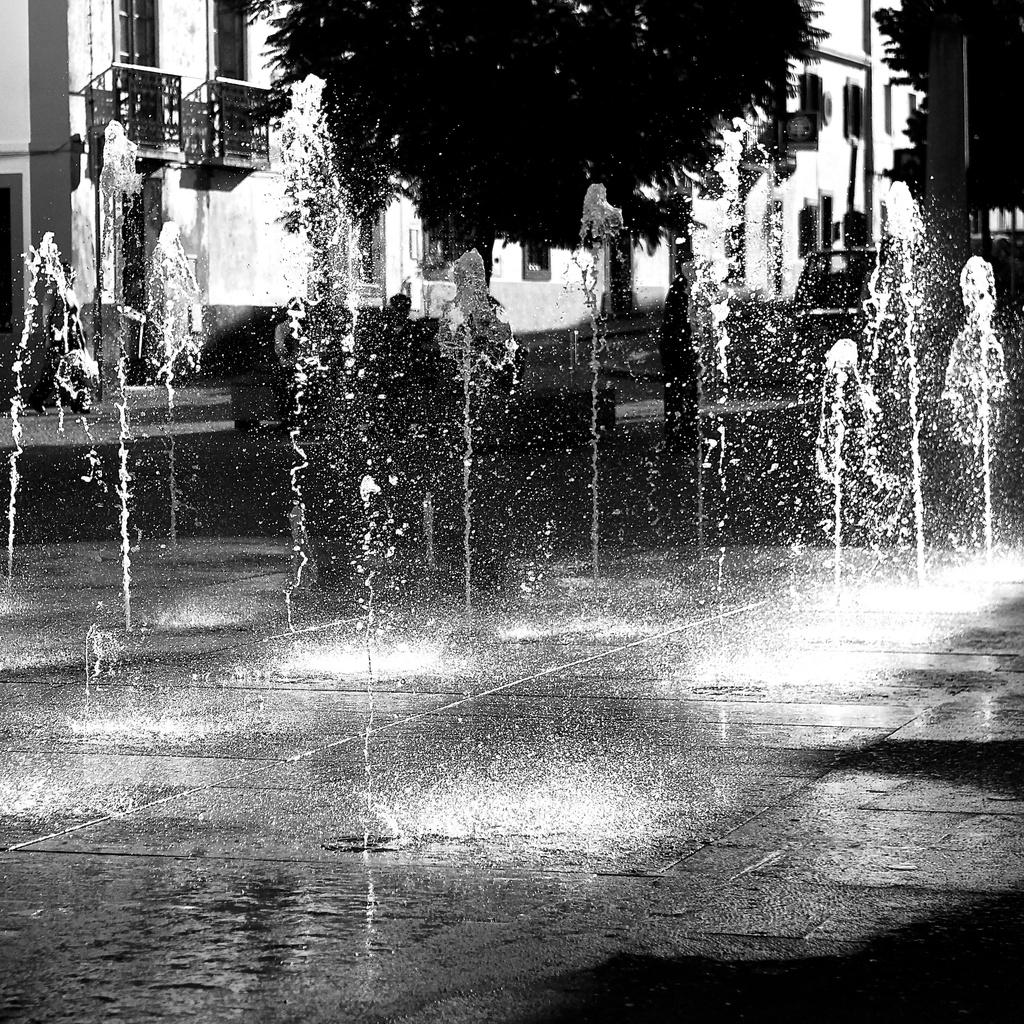What is located in the foreground of the image? There are fountains in the foreground of the image. What is the color scheme of the image? The image is in black and white. What can be seen in the background of the image? There are trees, buildings, and vehicles in the background of the image. Can you tell me how many owls are perched on the trees in the image? There are no owls present in the image; it features fountains, trees, buildings, and vehicles. What type of scientific experiment is being conducted in the image? There is no scientific experiment being conducted in the image; it is a scene with fountains, trees, buildings, and vehicles. 